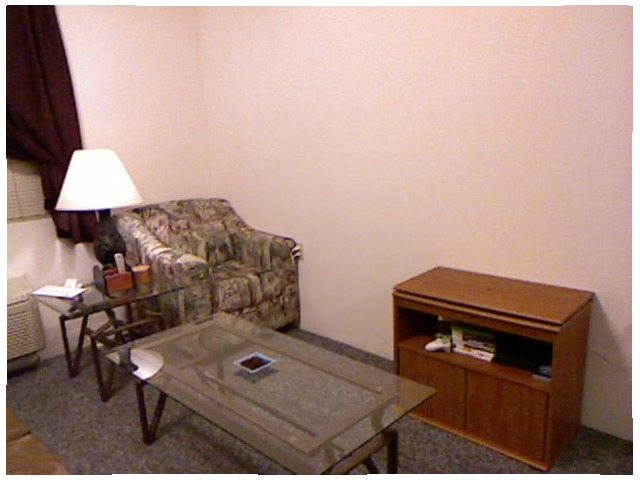<image>
Can you confirm if the console controller is in front of the shelf? No. The console controller is not in front of the shelf. The spatial positioning shows a different relationship between these objects. Where is the lamp in relation to the table? Is it on the table? No. The lamp is not positioned on the table. They may be near each other, but the lamp is not supported by or resting on top of the table. Is there a table on the dresser? No. The table is not positioned on the dresser. They may be near each other, but the table is not supported by or resting on top of the dresser. Is the table on the cushion? No. The table is not positioned on the cushion. They may be near each other, but the table is not supported by or resting on top of the cushion. 